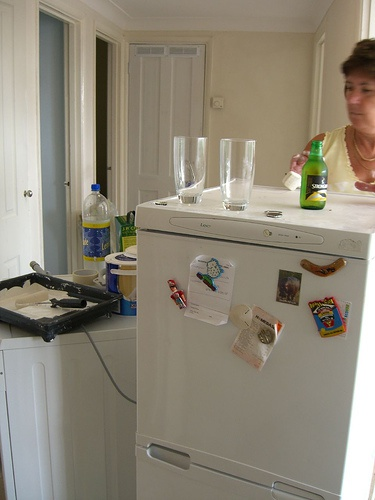Describe the objects in this image and their specific colors. I can see refrigerator in gray and darkgray tones, people in gray, brown, and tan tones, cup in gray, darkgray, and lightgray tones, bottle in gray, navy, and darkgray tones, and cup in gray, darkgray, and lightgray tones in this image. 